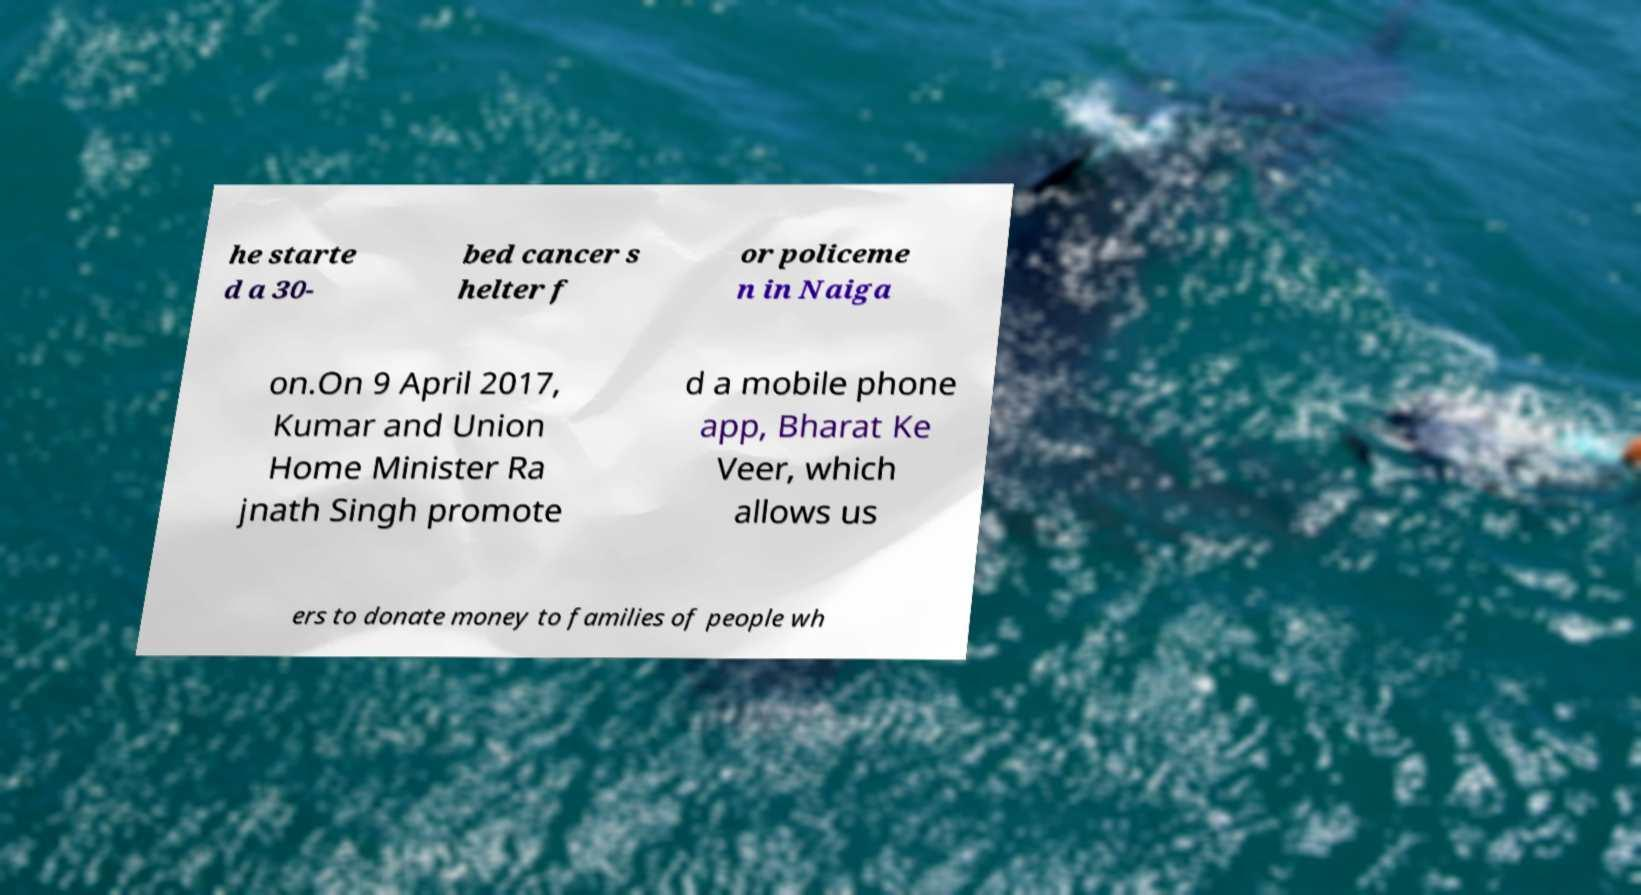Could you assist in decoding the text presented in this image and type it out clearly? he starte d a 30- bed cancer s helter f or policeme n in Naiga on.On 9 April 2017, Kumar and Union Home Minister Ra jnath Singh promote d a mobile phone app, Bharat Ke Veer, which allows us ers to donate money to families of people wh 